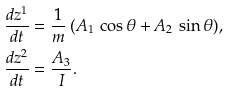Convert formula to latex. <formula><loc_0><loc_0><loc_500><loc_500>& \frac { d z ^ { 1 } } { d t } = \frac { 1 } { m } \, ( A _ { 1 } \, \cos \theta + A _ { 2 } \, \sin \theta ) , \\ & \frac { d z ^ { 2 } } { d t } = \frac { A _ { 3 } } I .</formula> 